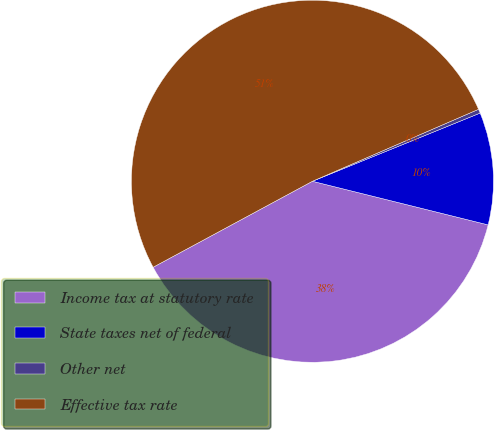Convert chart. <chart><loc_0><loc_0><loc_500><loc_500><pie_chart><fcel>Income tax at statutory rate<fcel>State taxes net of federal<fcel>Other net<fcel>Effective tax rate<nl><fcel>38.25%<fcel>10.02%<fcel>0.36%<fcel>51.37%<nl></chart> 